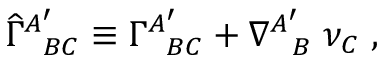<formula> <loc_0><loc_0><loc_500><loc_500>{ \widehat { \Gamma } } _ { \, B C } ^ { A ^ { \prime } } \equiv \Gamma _ { \, B C } ^ { A ^ { \prime } } + \nabla _ { \, B } ^ { A ^ { \prime } } \, \nu _ { C } \, ,</formula> 